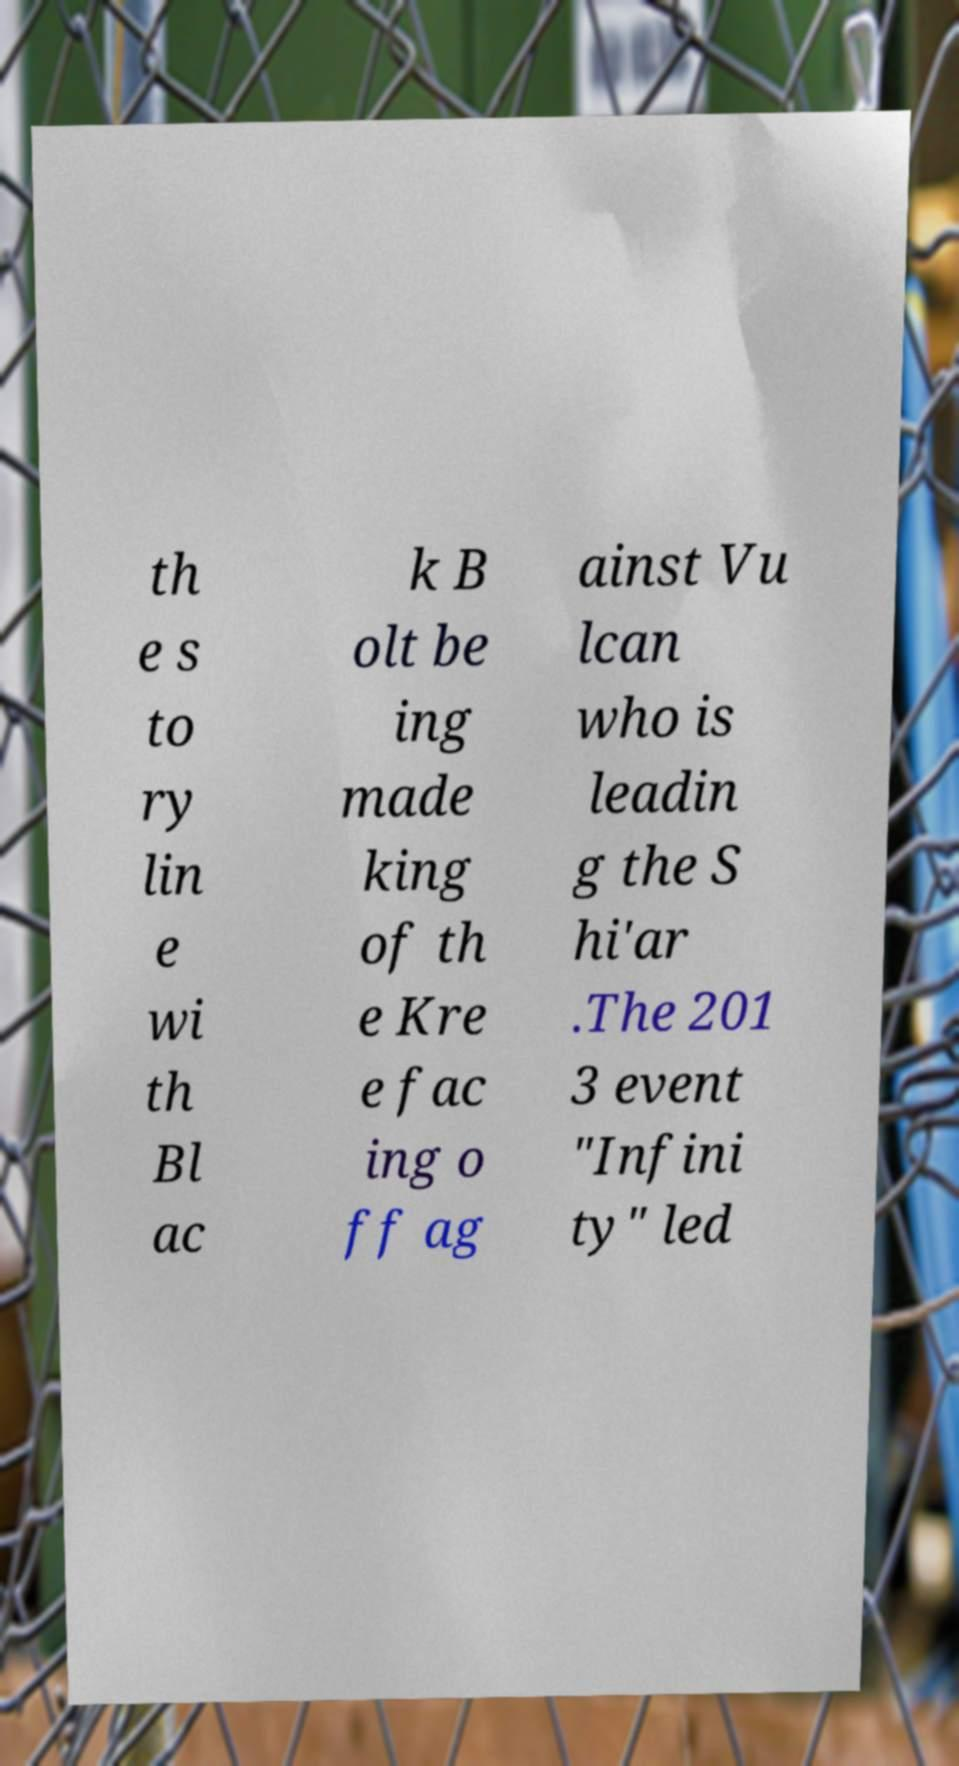There's text embedded in this image that I need extracted. Can you transcribe it verbatim? th e s to ry lin e wi th Bl ac k B olt be ing made king of th e Kre e fac ing o ff ag ainst Vu lcan who is leadin g the S hi'ar .The 201 3 event "Infini ty" led 